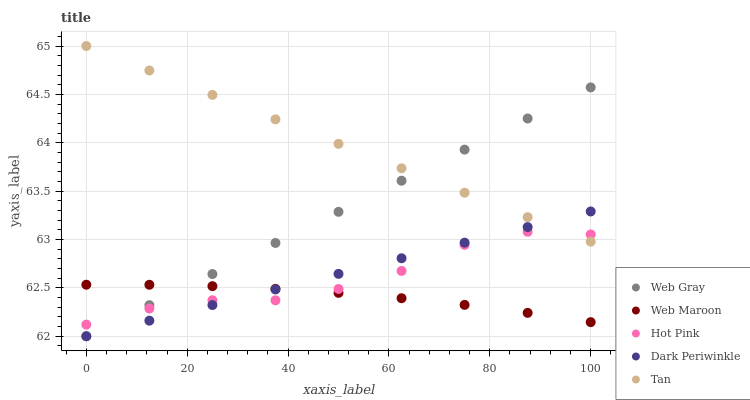Does Web Maroon have the minimum area under the curve?
Answer yes or no. Yes. Does Tan have the maximum area under the curve?
Answer yes or no. Yes. Does Web Gray have the minimum area under the curve?
Answer yes or no. No. Does Web Gray have the maximum area under the curve?
Answer yes or no. No. Is Dark Periwinkle the smoothest?
Answer yes or no. Yes. Is Hot Pink the roughest?
Answer yes or no. Yes. Is Web Gray the smoothest?
Answer yes or no. No. Is Web Gray the roughest?
Answer yes or no. No. Does Web Gray have the lowest value?
Answer yes or no. Yes. Does Web Maroon have the lowest value?
Answer yes or no. No. Does Tan have the highest value?
Answer yes or no. Yes. Does Web Gray have the highest value?
Answer yes or no. No. Is Web Maroon less than Tan?
Answer yes or no. Yes. Is Tan greater than Web Maroon?
Answer yes or no. Yes. Does Dark Periwinkle intersect Hot Pink?
Answer yes or no. Yes. Is Dark Periwinkle less than Hot Pink?
Answer yes or no. No. Is Dark Periwinkle greater than Hot Pink?
Answer yes or no. No. Does Web Maroon intersect Tan?
Answer yes or no. No. 